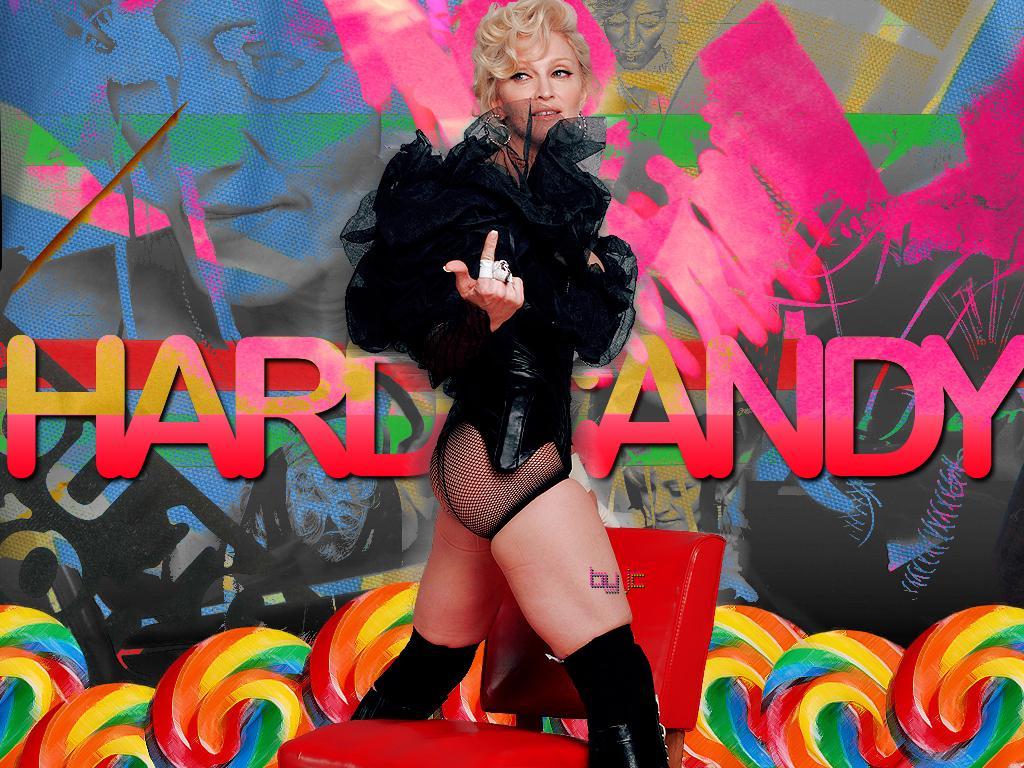In one or two sentences, can you explain what this image depicts? In this image, we can see a person on the colorful background. This person is wearing clothes. There is a chair at the bottom of the image. There is a text in the middle of the image. 